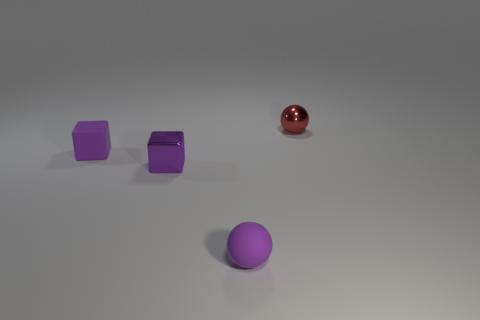Subtract all red blocks. Subtract all red cylinders. How many blocks are left? 2 Subtract all green blocks. How many purple spheres are left? 1 Subtract all large cyan shiny cubes. Subtract all small purple shiny objects. How many objects are left? 3 Add 2 small metallic cubes. How many small metallic cubes are left? 3 Add 1 tiny blue metallic spheres. How many tiny blue metallic spheres exist? 1 Add 1 big brown shiny things. How many objects exist? 5 Subtract all purple spheres. How many spheres are left? 1 Subtract 0 yellow cylinders. How many objects are left? 4 Subtract 1 blocks. How many blocks are left? 1 